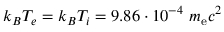Convert formula to latex. <formula><loc_0><loc_0><loc_500><loc_500>k _ { B } T _ { e } = k _ { B } T _ { i } = 9 . 8 6 \cdot 1 0 ^ { - 4 } m _ { e } c ^ { 2 }</formula> 